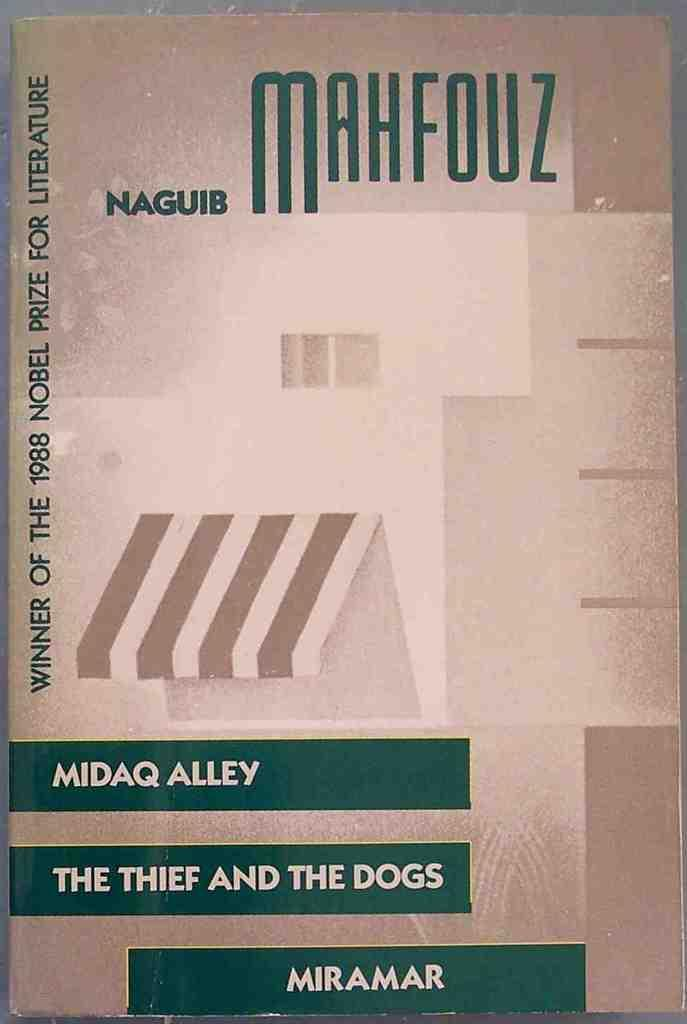<image>
Summarize the visual content of the image. A book by the author known as Naguib Mahfouz 